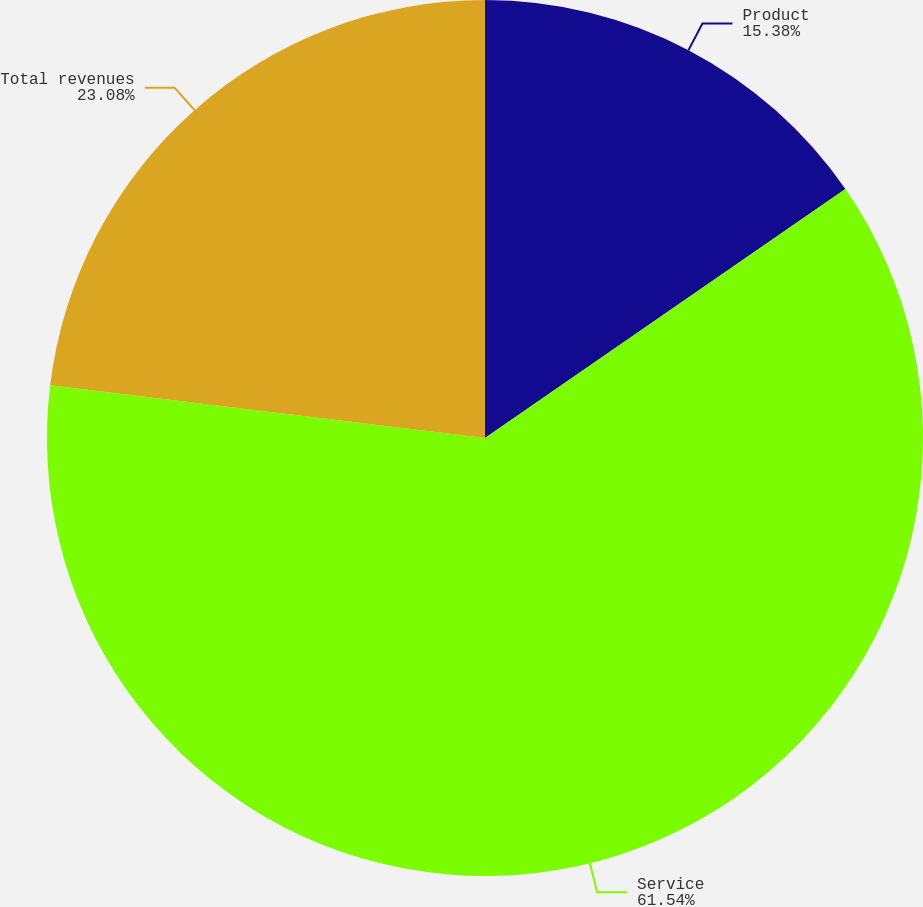Convert chart to OTSL. <chart><loc_0><loc_0><loc_500><loc_500><pie_chart><fcel>Product<fcel>Service<fcel>Total revenues<nl><fcel>15.38%<fcel>61.54%<fcel>23.08%<nl></chart> 